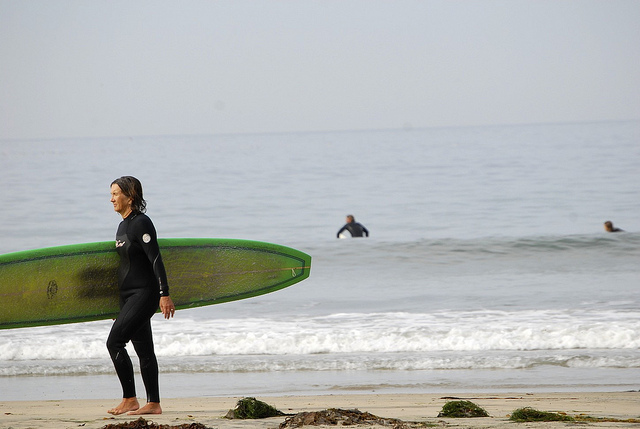What kind of preparations do the surfers need to make before hitting the waves? Before hitting the waves, the surfers need to make several preparations. They would start by checking the weather forecast and tide schedules to ensure optimal surfing conditions. Ensuring they have the right gear is essential, including wetsuits appropriate for the water temperature and surfboards suited to their skill level and the wave conditions. They would likely apply sunscreen to protect against UV rays, even if the sky is overcast. Stretches and warm-up exercises are important to prevent injuries. Lastly, a quick safety check, like making sure their surfboard is securely leashed to their ankle and reviewing potential hazards in the water, would be essential. These preparations help ensure a safe and enjoyable surfing experience. Could you describe the experience of riding a wave for the first time? Riding a wave for the first time is an exhilarating and unforgettable experience. As the wave begins to swell, there's a moment of anticipation and a surge of adrenaline. Paddling vigorously to catch the wave, you'll feel the board gain speed as it’s propelled forward by the ocean's power. Standing up on the board, balancing becomes a thrilling challenge as the water rushes beneath. The sensation of gliding across the wave’s surface feels almost like flying, with the wind in your face and the rhythmic sound of the water swirling around you. Each second is filled with a mix of triumph, excitement, and a connection with the natural world, creating a memory that will last a lifetime. Imagine if the ocean had a voice and it could talk to the surfers. What might it say to them? If the ocean had a voice and could talk to the surfers, it might say, 'Welcome, brave souls of the sea. Feel my rhythm, ride my waves, and embrace the harmony of nature. Respect my power and I will guide you to thrilling adventures. Together, we will dance with the tides, share moments of tranquility, and challenge your spirit. Each wave you ride is a story we write together, a bond between the earth and the daring. Listen to my whispers, adapt to my changes, and savor the freedom I offer. Surf with me, and you will discover the depths of your courage and the heights of your joy.' 